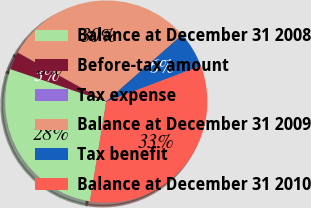Convert chart to OTSL. <chart><loc_0><loc_0><loc_500><loc_500><pie_chart><fcel>Balance at December 31 2008<fcel>Before-tax amount<fcel>Tax expense<fcel>Balance at December 31 2009<fcel>Tax benefit<fcel>Balance at December 31 2010<nl><fcel>27.62%<fcel>2.86%<fcel>0.01%<fcel>30.47%<fcel>5.71%<fcel>33.33%<nl></chart> 